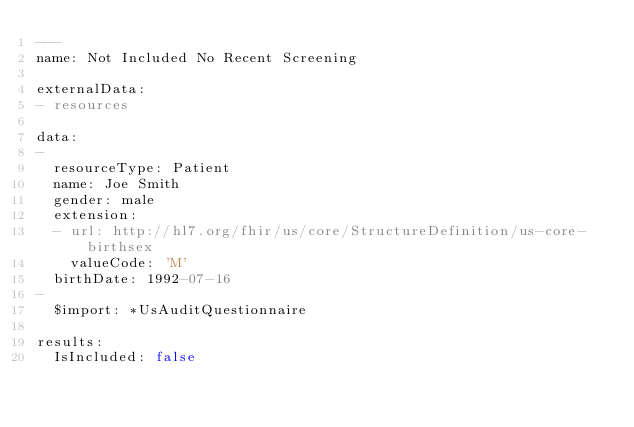<code> <loc_0><loc_0><loc_500><loc_500><_YAML_>---
name: Not Included No Recent Screening

externalData:
- resources

data:
-
  resourceType: Patient
  name: Joe Smith
  gender: male
  extension:
  - url: http://hl7.org/fhir/us/core/StructureDefinition/us-core-birthsex
    valueCode: 'M'
  birthDate: 1992-07-16
- 
  $import: *UsAuditQuestionnaire

results:
  IsIncluded: false</code> 